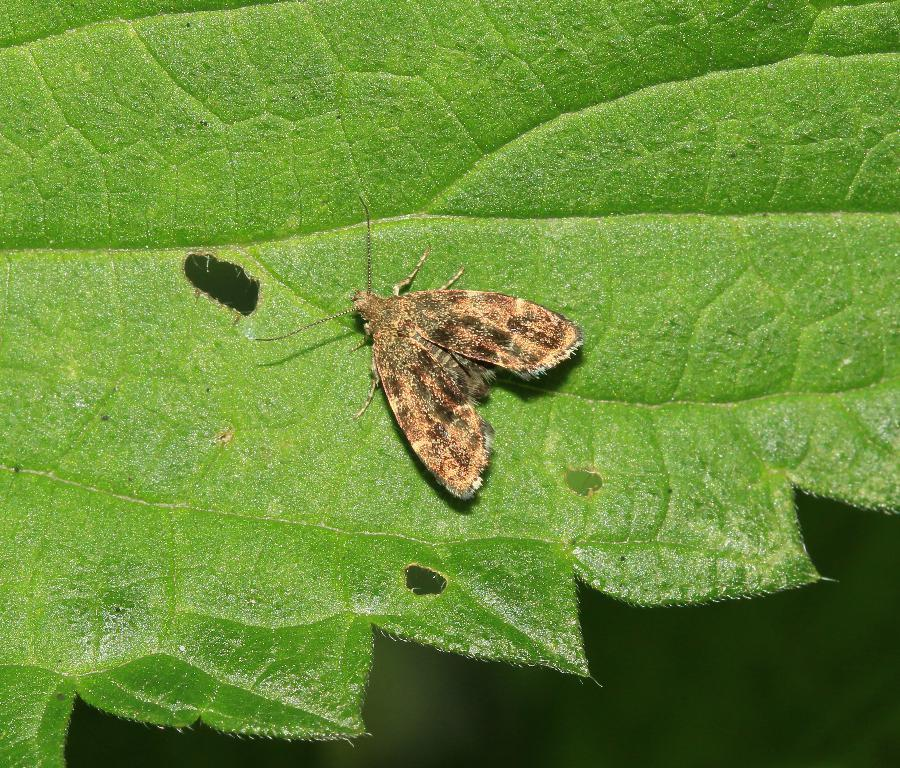What type of creature can be seen in the image? There is an insect in the image. Where is the insect located? The insect is on a leaf. What type of cheese is being served as a meal in the image? There is no cheese or meal present in the image; it features an insect on a leaf. 